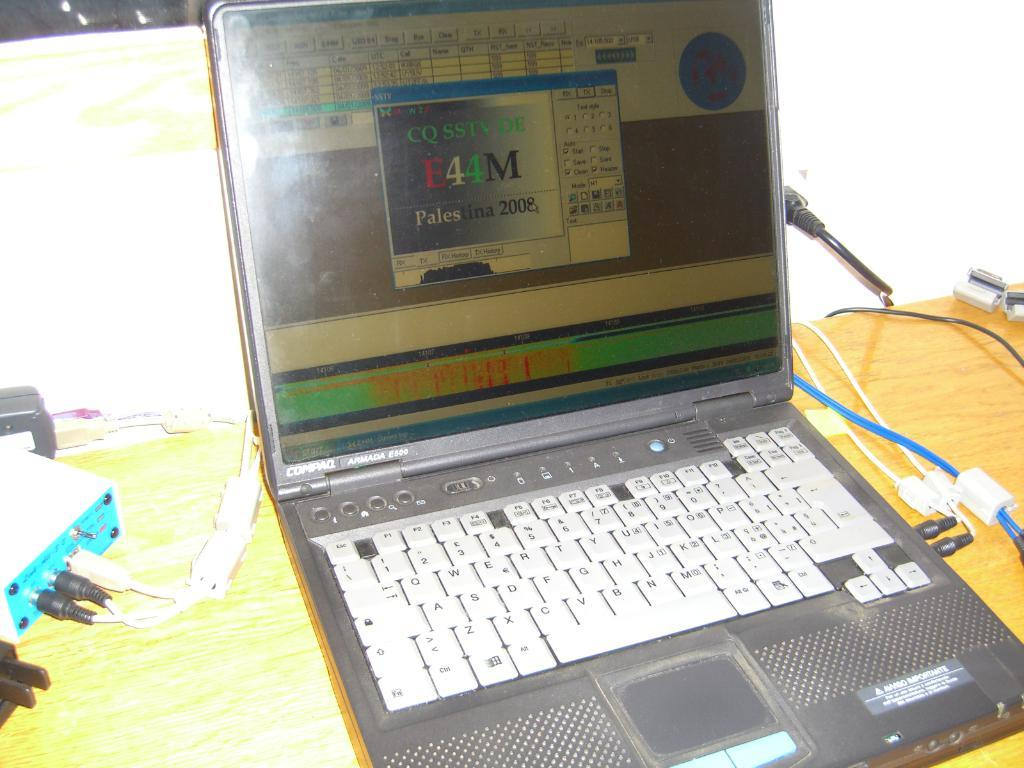Provide a one-sentence caption for the provided image. A program is open on a laptop made by Compaq. 